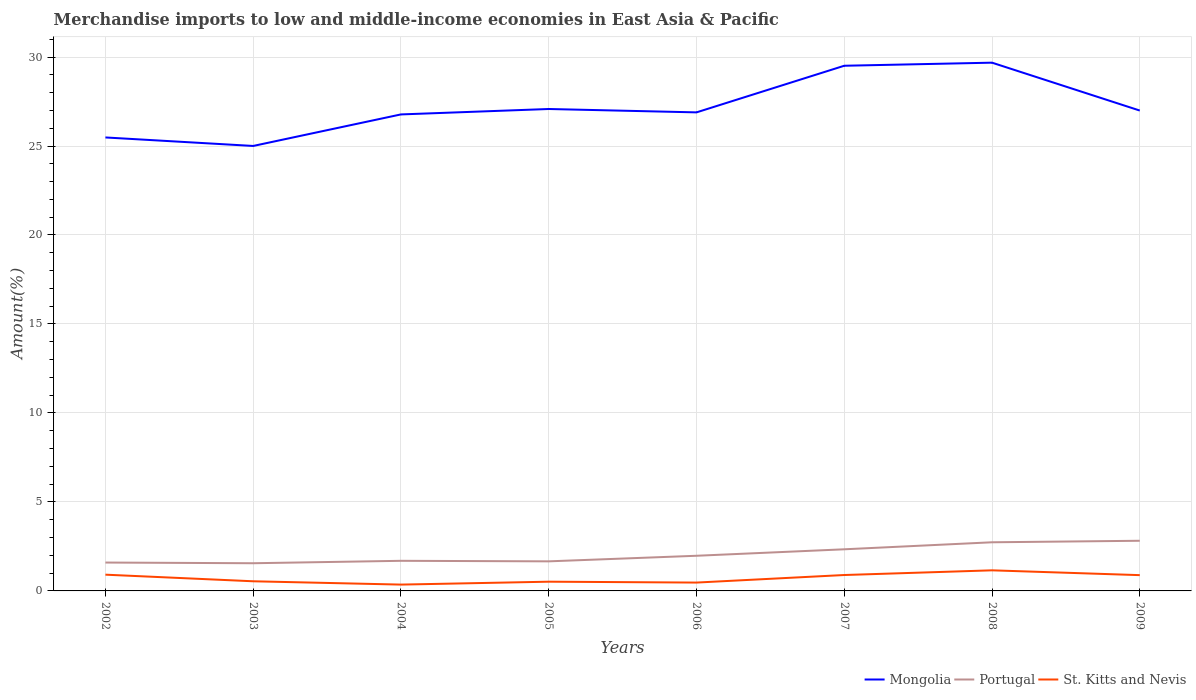Does the line corresponding to St. Kitts and Nevis intersect with the line corresponding to Portugal?
Ensure brevity in your answer.  No. Is the number of lines equal to the number of legend labels?
Your answer should be compact. Yes. Across all years, what is the maximum percentage of amount earned from merchandise imports in Mongolia?
Your answer should be compact. 25. What is the total percentage of amount earned from merchandise imports in Mongolia in the graph?
Your answer should be compact. -0.17. What is the difference between the highest and the second highest percentage of amount earned from merchandise imports in Mongolia?
Your response must be concise. 4.68. What is the difference between the highest and the lowest percentage of amount earned from merchandise imports in Mongolia?
Your answer should be compact. 2. How many lines are there?
Provide a short and direct response. 3. Are the values on the major ticks of Y-axis written in scientific E-notation?
Give a very brief answer. No. Does the graph contain any zero values?
Your answer should be compact. No. Does the graph contain grids?
Provide a succinct answer. Yes. How many legend labels are there?
Ensure brevity in your answer.  3. What is the title of the graph?
Provide a succinct answer. Merchandise imports to low and middle-income economies in East Asia & Pacific. Does "India" appear as one of the legend labels in the graph?
Make the answer very short. No. What is the label or title of the X-axis?
Make the answer very short. Years. What is the label or title of the Y-axis?
Make the answer very short. Amount(%). What is the Amount(%) of Mongolia in 2002?
Your answer should be compact. 25.48. What is the Amount(%) in Portugal in 2002?
Offer a terse response. 1.59. What is the Amount(%) of St. Kitts and Nevis in 2002?
Your response must be concise. 0.91. What is the Amount(%) of Mongolia in 2003?
Your answer should be compact. 25. What is the Amount(%) in Portugal in 2003?
Give a very brief answer. 1.56. What is the Amount(%) in St. Kitts and Nevis in 2003?
Ensure brevity in your answer.  0.54. What is the Amount(%) of Mongolia in 2004?
Offer a terse response. 26.78. What is the Amount(%) in Portugal in 2004?
Keep it short and to the point. 1.69. What is the Amount(%) of St. Kitts and Nevis in 2004?
Your answer should be compact. 0.36. What is the Amount(%) in Mongolia in 2005?
Provide a short and direct response. 27.08. What is the Amount(%) of Portugal in 2005?
Provide a succinct answer. 1.66. What is the Amount(%) in St. Kitts and Nevis in 2005?
Provide a succinct answer. 0.52. What is the Amount(%) in Mongolia in 2006?
Make the answer very short. 26.89. What is the Amount(%) in Portugal in 2006?
Provide a short and direct response. 1.98. What is the Amount(%) in St. Kitts and Nevis in 2006?
Your answer should be very brief. 0.47. What is the Amount(%) of Mongolia in 2007?
Offer a very short reply. 29.51. What is the Amount(%) in Portugal in 2007?
Give a very brief answer. 2.34. What is the Amount(%) of St. Kitts and Nevis in 2007?
Your response must be concise. 0.89. What is the Amount(%) in Mongolia in 2008?
Keep it short and to the point. 29.68. What is the Amount(%) of Portugal in 2008?
Your response must be concise. 2.73. What is the Amount(%) in St. Kitts and Nevis in 2008?
Your answer should be compact. 1.16. What is the Amount(%) of Mongolia in 2009?
Your response must be concise. 26.99. What is the Amount(%) in Portugal in 2009?
Your response must be concise. 2.82. What is the Amount(%) in St. Kitts and Nevis in 2009?
Keep it short and to the point. 0.89. Across all years, what is the maximum Amount(%) in Mongolia?
Provide a short and direct response. 29.68. Across all years, what is the maximum Amount(%) of Portugal?
Give a very brief answer. 2.82. Across all years, what is the maximum Amount(%) of St. Kitts and Nevis?
Your response must be concise. 1.16. Across all years, what is the minimum Amount(%) in Mongolia?
Provide a short and direct response. 25. Across all years, what is the minimum Amount(%) in Portugal?
Your response must be concise. 1.56. Across all years, what is the minimum Amount(%) of St. Kitts and Nevis?
Ensure brevity in your answer.  0.36. What is the total Amount(%) of Mongolia in the graph?
Provide a succinct answer. 217.42. What is the total Amount(%) in Portugal in the graph?
Keep it short and to the point. 16.37. What is the total Amount(%) of St. Kitts and Nevis in the graph?
Provide a short and direct response. 5.74. What is the difference between the Amount(%) in Mongolia in 2002 and that in 2003?
Your answer should be compact. 0.48. What is the difference between the Amount(%) of Portugal in 2002 and that in 2003?
Offer a very short reply. 0.04. What is the difference between the Amount(%) of St. Kitts and Nevis in 2002 and that in 2003?
Provide a short and direct response. 0.37. What is the difference between the Amount(%) in Mongolia in 2002 and that in 2004?
Provide a short and direct response. -1.29. What is the difference between the Amount(%) in Portugal in 2002 and that in 2004?
Provide a succinct answer. -0.1. What is the difference between the Amount(%) in St. Kitts and Nevis in 2002 and that in 2004?
Your response must be concise. 0.56. What is the difference between the Amount(%) in Mongolia in 2002 and that in 2005?
Keep it short and to the point. -1.6. What is the difference between the Amount(%) in Portugal in 2002 and that in 2005?
Provide a short and direct response. -0.07. What is the difference between the Amount(%) in St. Kitts and Nevis in 2002 and that in 2005?
Make the answer very short. 0.39. What is the difference between the Amount(%) of Mongolia in 2002 and that in 2006?
Your response must be concise. -1.41. What is the difference between the Amount(%) in Portugal in 2002 and that in 2006?
Your answer should be very brief. -0.38. What is the difference between the Amount(%) in St. Kitts and Nevis in 2002 and that in 2006?
Offer a very short reply. 0.44. What is the difference between the Amount(%) in Mongolia in 2002 and that in 2007?
Offer a very short reply. -4.03. What is the difference between the Amount(%) in Portugal in 2002 and that in 2007?
Your answer should be very brief. -0.74. What is the difference between the Amount(%) in St. Kitts and Nevis in 2002 and that in 2007?
Give a very brief answer. 0.02. What is the difference between the Amount(%) in Mongolia in 2002 and that in 2008?
Keep it short and to the point. -4.2. What is the difference between the Amount(%) of Portugal in 2002 and that in 2008?
Offer a terse response. -1.14. What is the difference between the Amount(%) in St. Kitts and Nevis in 2002 and that in 2008?
Offer a terse response. -0.24. What is the difference between the Amount(%) of Mongolia in 2002 and that in 2009?
Your answer should be compact. -1.51. What is the difference between the Amount(%) of Portugal in 2002 and that in 2009?
Offer a very short reply. -1.22. What is the difference between the Amount(%) of St. Kitts and Nevis in 2002 and that in 2009?
Give a very brief answer. 0.03. What is the difference between the Amount(%) of Mongolia in 2003 and that in 2004?
Offer a very short reply. -1.77. What is the difference between the Amount(%) of Portugal in 2003 and that in 2004?
Ensure brevity in your answer.  -0.14. What is the difference between the Amount(%) of St. Kitts and Nevis in 2003 and that in 2004?
Offer a terse response. 0.19. What is the difference between the Amount(%) of Mongolia in 2003 and that in 2005?
Give a very brief answer. -2.08. What is the difference between the Amount(%) in Portugal in 2003 and that in 2005?
Your answer should be compact. -0.11. What is the difference between the Amount(%) in St. Kitts and Nevis in 2003 and that in 2005?
Your answer should be very brief. 0.02. What is the difference between the Amount(%) of Mongolia in 2003 and that in 2006?
Offer a very short reply. -1.89. What is the difference between the Amount(%) of Portugal in 2003 and that in 2006?
Your answer should be compact. -0.42. What is the difference between the Amount(%) in St. Kitts and Nevis in 2003 and that in 2006?
Your answer should be very brief. 0.07. What is the difference between the Amount(%) in Mongolia in 2003 and that in 2007?
Your response must be concise. -4.51. What is the difference between the Amount(%) of Portugal in 2003 and that in 2007?
Provide a succinct answer. -0.78. What is the difference between the Amount(%) of St. Kitts and Nevis in 2003 and that in 2007?
Make the answer very short. -0.35. What is the difference between the Amount(%) in Mongolia in 2003 and that in 2008?
Your response must be concise. -4.68. What is the difference between the Amount(%) in Portugal in 2003 and that in 2008?
Keep it short and to the point. -1.18. What is the difference between the Amount(%) in St. Kitts and Nevis in 2003 and that in 2008?
Give a very brief answer. -0.61. What is the difference between the Amount(%) of Mongolia in 2003 and that in 2009?
Your response must be concise. -1.99. What is the difference between the Amount(%) of Portugal in 2003 and that in 2009?
Your answer should be very brief. -1.26. What is the difference between the Amount(%) of St. Kitts and Nevis in 2003 and that in 2009?
Give a very brief answer. -0.34. What is the difference between the Amount(%) in Mongolia in 2004 and that in 2005?
Your answer should be compact. -0.3. What is the difference between the Amount(%) in Portugal in 2004 and that in 2005?
Ensure brevity in your answer.  0.03. What is the difference between the Amount(%) of St. Kitts and Nevis in 2004 and that in 2005?
Provide a succinct answer. -0.16. What is the difference between the Amount(%) of Mongolia in 2004 and that in 2006?
Your response must be concise. -0.11. What is the difference between the Amount(%) of Portugal in 2004 and that in 2006?
Keep it short and to the point. -0.28. What is the difference between the Amount(%) in St. Kitts and Nevis in 2004 and that in 2006?
Keep it short and to the point. -0.11. What is the difference between the Amount(%) in Mongolia in 2004 and that in 2007?
Give a very brief answer. -2.73. What is the difference between the Amount(%) in Portugal in 2004 and that in 2007?
Give a very brief answer. -0.65. What is the difference between the Amount(%) in St. Kitts and Nevis in 2004 and that in 2007?
Provide a succinct answer. -0.54. What is the difference between the Amount(%) in Mongolia in 2004 and that in 2008?
Provide a succinct answer. -2.91. What is the difference between the Amount(%) of Portugal in 2004 and that in 2008?
Offer a terse response. -1.04. What is the difference between the Amount(%) in St. Kitts and Nevis in 2004 and that in 2008?
Provide a succinct answer. -0.8. What is the difference between the Amount(%) in Mongolia in 2004 and that in 2009?
Keep it short and to the point. -0.22. What is the difference between the Amount(%) in Portugal in 2004 and that in 2009?
Provide a succinct answer. -1.13. What is the difference between the Amount(%) of St. Kitts and Nevis in 2004 and that in 2009?
Ensure brevity in your answer.  -0.53. What is the difference between the Amount(%) in Mongolia in 2005 and that in 2006?
Make the answer very short. 0.19. What is the difference between the Amount(%) in Portugal in 2005 and that in 2006?
Your response must be concise. -0.31. What is the difference between the Amount(%) of St. Kitts and Nevis in 2005 and that in 2006?
Give a very brief answer. 0.05. What is the difference between the Amount(%) of Mongolia in 2005 and that in 2007?
Provide a short and direct response. -2.43. What is the difference between the Amount(%) of Portugal in 2005 and that in 2007?
Make the answer very short. -0.68. What is the difference between the Amount(%) of St. Kitts and Nevis in 2005 and that in 2007?
Your answer should be compact. -0.38. What is the difference between the Amount(%) in Mongolia in 2005 and that in 2008?
Offer a terse response. -2.6. What is the difference between the Amount(%) of Portugal in 2005 and that in 2008?
Make the answer very short. -1.07. What is the difference between the Amount(%) of St. Kitts and Nevis in 2005 and that in 2008?
Offer a very short reply. -0.64. What is the difference between the Amount(%) in Mongolia in 2005 and that in 2009?
Keep it short and to the point. 0.09. What is the difference between the Amount(%) of Portugal in 2005 and that in 2009?
Make the answer very short. -1.16. What is the difference between the Amount(%) of St. Kitts and Nevis in 2005 and that in 2009?
Ensure brevity in your answer.  -0.37. What is the difference between the Amount(%) in Mongolia in 2006 and that in 2007?
Keep it short and to the point. -2.62. What is the difference between the Amount(%) in Portugal in 2006 and that in 2007?
Offer a terse response. -0.36. What is the difference between the Amount(%) in St. Kitts and Nevis in 2006 and that in 2007?
Provide a succinct answer. -0.42. What is the difference between the Amount(%) of Mongolia in 2006 and that in 2008?
Make the answer very short. -2.79. What is the difference between the Amount(%) in Portugal in 2006 and that in 2008?
Keep it short and to the point. -0.76. What is the difference between the Amount(%) in St. Kitts and Nevis in 2006 and that in 2008?
Provide a succinct answer. -0.69. What is the difference between the Amount(%) of Mongolia in 2006 and that in 2009?
Keep it short and to the point. -0.1. What is the difference between the Amount(%) of Portugal in 2006 and that in 2009?
Offer a very short reply. -0.84. What is the difference between the Amount(%) of St. Kitts and Nevis in 2006 and that in 2009?
Provide a succinct answer. -0.42. What is the difference between the Amount(%) of Mongolia in 2007 and that in 2008?
Offer a very short reply. -0.17. What is the difference between the Amount(%) in Portugal in 2007 and that in 2008?
Make the answer very short. -0.39. What is the difference between the Amount(%) of St. Kitts and Nevis in 2007 and that in 2008?
Provide a short and direct response. -0.26. What is the difference between the Amount(%) of Mongolia in 2007 and that in 2009?
Offer a very short reply. 2.52. What is the difference between the Amount(%) in Portugal in 2007 and that in 2009?
Make the answer very short. -0.48. What is the difference between the Amount(%) in St. Kitts and Nevis in 2007 and that in 2009?
Ensure brevity in your answer.  0.01. What is the difference between the Amount(%) of Mongolia in 2008 and that in 2009?
Make the answer very short. 2.69. What is the difference between the Amount(%) in Portugal in 2008 and that in 2009?
Provide a succinct answer. -0.09. What is the difference between the Amount(%) of St. Kitts and Nevis in 2008 and that in 2009?
Your answer should be compact. 0.27. What is the difference between the Amount(%) of Mongolia in 2002 and the Amount(%) of Portugal in 2003?
Give a very brief answer. 23.92. What is the difference between the Amount(%) in Mongolia in 2002 and the Amount(%) in St. Kitts and Nevis in 2003?
Offer a terse response. 24.94. What is the difference between the Amount(%) of Portugal in 2002 and the Amount(%) of St. Kitts and Nevis in 2003?
Offer a very short reply. 1.05. What is the difference between the Amount(%) of Mongolia in 2002 and the Amount(%) of Portugal in 2004?
Offer a terse response. 23.79. What is the difference between the Amount(%) of Mongolia in 2002 and the Amount(%) of St. Kitts and Nevis in 2004?
Offer a terse response. 25.12. What is the difference between the Amount(%) of Portugal in 2002 and the Amount(%) of St. Kitts and Nevis in 2004?
Make the answer very short. 1.24. What is the difference between the Amount(%) in Mongolia in 2002 and the Amount(%) in Portugal in 2005?
Provide a short and direct response. 23.82. What is the difference between the Amount(%) in Mongolia in 2002 and the Amount(%) in St. Kitts and Nevis in 2005?
Offer a terse response. 24.96. What is the difference between the Amount(%) of Portugal in 2002 and the Amount(%) of St. Kitts and Nevis in 2005?
Provide a succinct answer. 1.08. What is the difference between the Amount(%) in Mongolia in 2002 and the Amount(%) in Portugal in 2006?
Make the answer very short. 23.51. What is the difference between the Amount(%) in Mongolia in 2002 and the Amount(%) in St. Kitts and Nevis in 2006?
Ensure brevity in your answer.  25.01. What is the difference between the Amount(%) of Portugal in 2002 and the Amount(%) of St. Kitts and Nevis in 2006?
Your answer should be compact. 1.13. What is the difference between the Amount(%) of Mongolia in 2002 and the Amount(%) of Portugal in 2007?
Make the answer very short. 23.14. What is the difference between the Amount(%) of Mongolia in 2002 and the Amount(%) of St. Kitts and Nevis in 2007?
Your response must be concise. 24.59. What is the difference between the Amount(%) of Portugal in 2002 and the Amount(%) of St. Kitts and Nevis in 2007?
Your response must be concise. 0.7. What is the difference between the Amount(%) in Mongolia in 2002 and the Amount(%) in Portugal in 2008?
Offer a terse response. 22.75. What is the difference between the Amount(%) in Mongolia in 2002 and the Amount(%) in St. Kitts and Nevis in 2008?
Ensure brevity in your answer.  24.32. What is the difference between the Amount(%) of Portugal in 2002 and the Amount(%) of St. Kitts and Nevis in 2008?
Ensure brevity in your answer.  0.44. What is the difference between the Amount(%) in Mongolia in 2002 and the Amount(%) in Portugal in 2009?
Ensure brevity in your answer.  22.66. What is the difference between the Amount(%) in Mongolia in 2002 and the Amount(%) in St. Kitts and Nevis in 2009?
Provide a short and direct response. 24.59. What is the difference between the Amount(%) of Portugal in 2002 and the Amount(%) of St. Kitts and Nevis in 2009?
Your answer should be compact. 0.71. What is the difference between the Amount(%) of Mongolia in 2003 and the Amount(%) of Portugal in 2004?
Ensure brevity in your answer.  23.31. What is the difference between the Amount(%) of Mongolia in 2003 and the Amount(%) of St. Kitts and Nevis in 2004?
Make the answer very short. 24.65. What is the difference between the Amount(%) of Portugal in 2003 and the Amount(%) of St. Kitts and Nevis in 2004?
Ensure brevity in your answer.  1.2. What is the difference between the Amount(%) in Mongolia in 2003 and the Amount(%) in Portugal in 2005?
Make the answer very short. 23.34. What is the difference between the Amount(%) of Mongolia in 2003 and the Amount(%) of St. Kitts and Nevis in 2005?
Offer a very short reply. 24.49. What is the difference between the Amount(%) in Portugal in 2003 and the Amount(%) in St. Kitts and Nevis in 2005?
Your answer should be very brief. 1.04. What is the difference between the Amount(%) in Mongolia in 2003 and the Amount(%) in Portugal in 2006?
Offer a very short reply. 23.03. What is the difference between the Amount(%) of Mongolia in 2003 and the Amount(%) of St. Kitts and Nevis in 2006?
Your response must be concise. 24.53. What is the difference between the Amount(%) in Portugal in 2003 and the Amount(%) in St. Kitts and Nevis in 2006?
Offer a very short reply. 1.09. What is the difference between the Amount(%) of Mongolia in 2003 and the Amount(%) of Portugal in 2007?
Offer a terse response. 22.66. What is the difference between the Amount(%) of Mongolia in 2003 and the Amount(%) of St. Kitts and Nevis in 2007?
Provide a succinct answer. 24.11. What is the difference between the Amount(%) in Portugal in 2003 and the Amount(%) in St. Kitts and Nevis in 2007?
Your answer should be very brief. 0.66. What is the difference between the Amount(%) in Mongolia in 2003 and the Amount(%) in Portugal in 2008?
Your answer should be very brief. 22.27. What is the difference between the Amount(%) in Mongolia in 2003 and the Amount(%) in St. Kitts and Nevis in 2008?
Provide a short and direct response. 23.85. What is the difference between the Amount(%) in Portugal in 2003 and the Amount(%) in St. Kitts and Nevis in 2008?
Keep it short and to the point. 0.4. What is the difference between the Amount(%) in Mongolia in 2003 and the Amount(%) in Portugal in 2009?
Make the answer very short. 22.19. What is the difference between the Amount(%) in Mongolia in 2003 and the Amount(%) in St. Kitts and Nevis in 2009?
Your answer should be compact. 24.12. What is the difference between the Amount(%) of Portugal in 2003 and the Amount(%) of St. Kitts and Nevis in 2009?
Provide a succinct answer. 0.67. What is the difference between the Amount(%) in Mongolia in 2004 and the Amount(%) in Portugal in 2005?
Your response must be concise. 25.11. What is the difference between the Amount(%) of Mongolia in 2004 and the Amount(%) of St. Kitts and Nevis in 2005?
Offer a terse response. 26.26. What is the difference between the Amount(%) in Portugal in 2004 and the Amount(%) in St. Kitts and Nevis in 2005?
Offer a terse response. 1.17. What is the difference between the Amount(%) in Mongolia in 2004 and the Amount(%) in Portugal in 2006?
Provide a short and direct response. 24.8. What is the difference between the Amount(%) in Mongolia in 2004 and the Amount(%) in St. Kitts and Nevis in 2006?
Offer a terse response. 26.31. What is the difference between the Amount(%) of Portugal in 2004 and the Amount(%) of St. Kitts and Nevis in 2006?
Make the answer very short. 1.22. What is the difference between the Amount(%) in Mongolia in 2004 and the Amount(%) in Portugal in 2007?
Provide a succinct answer. 24.44. What is the difference between the Amount(%) in Mongolia in 2004 and the Amount(%) in St. Kitts and Nevis in 2007?
Provide a short and direct response. 25.88. What is the difference between the Amount(%) of Portugal in 2004 and the Amount(%) of St. Kitts and Nevis in 2007?
Provide a succinct answer. 0.8. What is the difference between the Amount(%) in Mongolia in 2004 and the Amount(%) in Portugal in 2008?
Your response must be concise. 24.04. What is the difference between the Amount(%) in Mongolia in 2004 and the Amount(%) in St. Kitts and Nevis in 2008?
Keep it short and to the point. 25.62. What is the difference between the Amount(%) in Portugal in 2004 and the Amount(%) in St. Kitts and Nevis in 2008?
Make the answer very short. 0.53. What is the difference between the Amount(%) in Mongolia in 2004 and the Amount(%) in Portugal in 2009?
Your answer should be compact. 23.96. What is the difference between the Amount(%) in Mongolia in 2004 and the Amount(%) in St. Kitts and Nevis in 2009?
Provide a succinct answer. 25.89. What is the difference between the Amount(%) in Portugal in 2004 and the Amount(%) in St. Kitts and Nevis in 2009?
Your answer should be compact. 0.81. What is the difference between the Amount(%) of Mongolia in 2005 and the Amount(%) of Portugal in 2006?
Your answer should be very brief. 25.1. What is the difference between the Amount(%) of Mongolia in 2005 and the Amount(%) of St. Kitts and Nevis in 2006?
Keep it short and to the point. 26.61. What is the difference between the Amount(%) in Portugal in 2005 and the Amount(%) in St. Kitts and Nevis in 2006?
Your answer should be compact. 1.19. What is the difference between the Amount(%) of Mongolia in 2005 and the Amount(%) of Portugal in 2007?
Your response must be concise. 24.74. What is the difference between the Amount(%) of Mongolia in 2005 and the Amount(%) of St. Kitts and Nevis in 2007?
Your answer should be very brief. 26.19. What is the difference between the Amount(%) of Portugal in 2005 and the Amount(%) of St. Kitts and Nevis in 2007?
Offer a very short reply. 0.77. What is the difference between the Amount(%) in Mongolia in 2005 and the Amount(%) in Portugal in 2008?
Keep it short and to the point. 24.35. What is the difference between the Amount(%) of Mongolia in 2005 and the Amount(%) of St. Kitts and Nevis in 2008?
Provide a short and direct response. 25.92. What is the difference between the Amount(%) in Portugal in 2005 and the Amount(%) in St. Kitts and Nevis in 2008?
Provide a succinct answer. 0.51. What is the difference between the Amount(%) of Mongolia in 2005 and the Amount(%) of Portugal in 2009?
Give a very brief answer. 24.26. What is the difference between the Amount(%) of Mongolia in 2005 and the Amount(%) of St. Kitts and Nevis in 2009?
Your response must be concise. 26.19. What is the difference between the Amount(%) of Portugal in 2005 and the Amount(%) of St. Kitts and Nevis in 2009?
Make the answer very short. 0.78. What is the difference between the Amount(%) of Mongolia in 2006 and the Amount(%) of Portugal in 2007?
Offer a terse response. 24.55. What is the difference between the Amount(%) in Mongolia in 2006 and the Amount(%) in St. Kitts and Nevis in 2007?
Provide a succinct answer. 26. What is the difference between the Amount(%) in Portugal in 2006 and the Amount(%) in St. Kitts and Nevis in 2007?
Keep it short and to the point. 1.08. What is the difference between the Amount(%) in Mongolia in 2006 and the Amount(%) in Portugal in 2008?
Provide a short and direct response. 24.16. What is the difference between the Amount(%) in Mongolia in 2006 and the Amount(%) in St. Kitts and Nevis in 2008?
Offer a terse response. 25.73. What is the difference between the Amount(%) in Portugal in 2006 and the Amount(%) in St. Kitts and Nevis in 2008?
Provide a short and direct response. 0.82. What is the difference between the Amount(%) of Mongolia in 2006 and the Amount(%) of Portugal in 2009?
Offer a terse response. 24.07. What is the difference between the Amount(%) in Mongolia in 2006 and the Amount(%) in St. Kitts and Nevis in 2009?
Provide a succinct answer. 26. What is the difference between the Amount(%) in Portugal in 2006 and the Amount(%) in St. Kitts and Nevis in 2009?
Give a very brief answer. 1.09. What is the difference between the Amount(%) in Mongolia in 2007 and the Amount(%) in Portugal in 2008?
Provide a succinct answer. 26.78. What is the difference between the Amount(%) in Mongolia in 2007 and the Amount(%) in St. Kitts and Nevis in 2008?
Offer a very short reply. 28.35. What is the difference between the Amount(%) in Portugal in 2007 and the Amount(%) in St. Kitts and Nevis in 2008?
Provide a short and direct response. 1.18. What is the difference between the Amount(%) of Mongolia in 2007 and the Amount(%) of Portugal in 2009?
Make the answer very short. 26.69. What is the difference between the Amount(%) of Mongolia in 2007 and the Amount(%) of St. Kitts and Nevis in 2009?
Give a very brief answer. 28.62. What is the difference between the Amount(%) in Portugal in 2007 and the Amount(%) in St. Kitts and Nevis in 2009?
Your answer should be very brief. 1.45. What is the difference between the Amount(%) in Mongolia in 2008 and the Amount(%) in Portugal in 2009?
Your answer should be very brief. 26.86. What is the difference between the Amount(%) in Mongolia in 2008 and the Amount(%) in St. Kitts and Nevis in 2009?
Offer a very short reply. 28.8. What is the difference between the Amount(%) of Portugal in 2008 and the Amount(%) of St. Kitts and Nevis in 2009?
Your answer should be very brief. 1.85. What is the average Amount(%) of Mongolia per year?
Your answer should be compact. 27.18. What is the average Amount(%) of Portugal per year?
Your answer should be compact. 2.05. What is the average Amount(%) in St. Kitts and Nevis per year?
Your response must be concise. 0.72. In the year 2002, what is the difference between the Amount(%) in Mongolia and Amount(%) in Portugal?
Your answer should be very brief. 23.89. In the year 2002, what is the difference between the Amount(%) in Mongolia and Amount(%) in St. Kitts and Nevis?
Provide a short and direct response. 24.57. In the year 2002, what is the difference between the Amount(%) of Portugal and Amount(%) of St. Kitts and Nevis?
Your answer should be very brief. 0.68. In the year 2003, what is the difference between the Amount(%) of Mongolia and Amount(%) of Portugal?
Offer a terse response. 23.45. In the year 2003, what is the difference between the Amount(%) in Mongolia and Amount(%) in St. Kitts and Nevis?
Offer a terse response. 24.46. In the year 2003, what is the difference between the Amount(%) in Portugal and Amount(%) in St. Kitts and Nevis?
Provide a short and direct response. 1.01. In the year 2004, what is the difference between the Amount(%) of Mongolia and Amount(%) of Portugal?
Your answer should be compact. 25.08. In the year 2004, what is the difference between the Amount(%) of Mongolia and Amount(%) of St. Kitts and Nevis?
Keep it short and to the point. 26.42. In the year 2004, what is the difference between the Amount(%) of Portugal and Amount(%) of St. Kitts and Nevis?
Offer a terse response. 1.34. In the year 2005, what is the difference between the Amount(%) of Mongolia and Amount(%) of Portugal?
Offer a terse response. 25.42. In the year 2005, what is the difference between the Amount(%) in Mongolia and Amount(%) in St. Kitts and Nevis?
Make the answer very short. 26.56. In the year 2005, what is the difference between the Amount(%) in Portugal and Amount(%) in St. Kitts and Nevis?
Your response must be concise. 1.14. In the year 2006, what is the difference between the Amount(%) in Mongolia and Amount(%) in Portugal?
Make the answer very short. 24.91. In the year 2006, what is the difference between the Amount(%) in Mongolia and Amount(%) in St. Kitts and Nevis?
Provide a succinct answer. 26.42. In the year 2006, what is the difference between the Amount(%) in Portugal and Amount(%) in St. Kitts and Nevis?
Make the answer very short. 1.51. In the year 2007, what is the difference between the Amount(%) of Mongolia and Amount(%) of Portugal?
Keep it short and to the point. 27.17. In the year 2007, what is the difference between the Amount(%) of Mongolia and Amount(%) of St. Kitts and Nevis?
Give a very brief answer. 28.62. In the year 2007, what is the difference between the Amount(%) of Portugal and Amount(%) of St. Kitts and Nevis?
Provide a short and direct response. 1.45. In the year 2008, what is the difference between the Amount(%) of Mongolia and Amount(%) of Portugal?
Keep it short and to the point. 26.95. In the year 2008, what is the difference between the Amount(%) in Mongolia and Amount(%) in St. Kitts and Nevis?
Your response must be concise. 28.53. In the year 2008, what is the difference between the Amount(%) of Portugal and Amount(%) of St. Kitts and Nevis?
Your answer should be compact. 1.58. In the year 2009, what is the difference between the Amount(%) of Mongolia and Amount(%) of Portugal?
Make the answer very short. 24.17. In the year 2009, what is the difference between the Amount(%) of Mongolia and Amount(%) of St. Kitts and Nevis?
Your response must be concise. 26.11. In the year 2009, what is the difference between the Amount(%) in Portugal and Amount(%) in St. Kitts and Nevis?
Provide a short and direct response. 1.93. What is the ratio of the Amount(%) in Mongolia in 2002 to that in 2003?
Give a very brief answer. 1.02. What is the ratio of the Amount(%) in Portugal in 2002 to that in 2003?
Offer a very short reply. 1.02. What is the ratio of the Amount(%) of St. Kitts and Nevis in 2002 to that in 2003?
Provide a short and direct response. 1.68. What is the ratio of the Amount(%) in Mongolia in 2002 to that in 2004?
Offer a terse response. 0.95. What is the ratio of the Amount(%) of Portugal in 2002 to that in 2004?
Your answer should be compact. 0.94. What is the ratio of the Amount(%) in St. Kitts and Nevis in 2002 to that in 2004?
Your answer should be very brief. 2.56. What is the ratio of the Amount(%) of Mongolia in 2002 to that in 2005?
Make the answer very short. 0.94. What is the ratio of the Amount(%) of Portugal in 2002 to that in 2005?
Your response must be concise. 0.96. What is the ratio of the Amount(%) in St. Kitts and Nevis in 2002 to that in 2005?
Give a very brief answer. 1.76. What is the ratio of the Amount(%) of Mongolia in 2002 to that in 2006?
Ensure brevity in your answer.  0.95. What is the ratio of the Amount(%) in Portugal in 2002 to that in 2006?
Offer a very short reply. 0.81. What is the ratio of the Amount(%) in St. Kitts and Nevis in 2002 to that in 2006?
Provide a short and direct response. 1.95. What is the ratio of the Amount(%) of Mongolia in 2002 to that in 2007?
Your response must be concise. 0.86. What is the ratio of the Amount(%) of Portugal in 2002 to that in 2007?
Keep it short and to the point. 0.68. What is the ratio of the Amount(%) of St. Kitts and Nevis in 2002 to that in 2007?
Make the answer very short. 1.02. What is the ratio of the Amount(%) of Mongolia in 2002 to that in 2008?
Make the answer very short. 0.86. What is the ratio of the Amount(%) in Portugal in 2002 to that in 2008?
Provide a short and direct response. 0.58. What is the ratio of the Amount(%) in St. Kitts and Nevis in 2002 to that in 2008?
Your answer should be very brief. 0.79. What is the ratio of the Amount(%) in Mongolia in 2002 to that in 2009?
Make the answer very short. 0.94. What is the ratio of the Amount(%) in Portugal in 2002 to that in 2009?
Your answer should be very brief. 0.57. What is the ratio of the Amount(%) in St. Kitts and Nevis in 2002 to that in 2009?
Your answer should be compact. 1.03. What is the ratio of the Amount(%) of Mongolia in 2003 to that in 2004?
Offer a very short reply. 0.93. What is the ratio of the Amount(%) in Portugal in 2003 to that in 2004?
Give a very brief answer. 0.92. What is the ratio of the Amount(%) of St. Kitts and Nevis in 2003 to that in 2004?
Provide a short and direct response. 1.52. What is the ratio of the Amount(%) in Mongolia in 2003 to that in 2005?
Ensure brevity in your answer.  0.92. What is the ratio of the Amount(%) of Portugal in 2003 to that in 2005?
Offer a terse response. 0.94. What is the ratio of the Amount(%) of St. Kitts and Nevis in 2003 to that in 2005?
Your answer should be compact. 1.05. What is the ratio of the Amount(%) in Mongolia in 2003 to that in 2006?
Provide a succinct answer. 0.93. What is the ratio of the Amount(%) in Portugal in 2003 to that in 2006?
Your answer should be very brief. 0.79. What is the ratio of the Amount(%) of St. Kitts and Nevis in 2003 to that in 2006?
Provide a succinct answer. 1.15. What is the ratio of the Amount(%) of Mongolia in 2003 to that in 2007?
Provide a succinct answer. 0.85. What is the ratio of the Amount(%) of Portugal in 2003 to that in 2007?
Keep it short and to the point. 0.67. What is the ratio of the Amount(%) in St. Kitts and Nevis in 2003 to that in 2007?
Offer a terse response. 0.61. What is the ratio of the Amount(%) in Mongolia in 2003 to that in 2008?
Keep it short and to the point. 0.84. What is the ratio of the Amount(%) in Portugal in 2003 to that in 2008?
Your response must be concise. 0.57. What is the ratio of the Amount(%) in St. Kitts and Nevis in 2003 to that in 2008?
Your answer should be very brief. 0.47. What is the ratio of the Amount(%) in Mongolia in 2003 to that in 2009?
Your response must be concise. 0.93. What is the ratio of the Amount(%) in Portugal in 2003 to that in 2009?
Make the answer very short. 0.55. What is the ratio of the Amount(%) in St. Kitts and Nevis in 2003 to that in 2009?
Your response must be concise. 0.61. What is the ratio of the Amount(%) of Mongolia in 2004 to that in 2005?
Give a very brief answer. 0.99. What is the ratio of the Amount(%) in Portugal in 2004 to that in 2005?
Your answer should be compact. 1.02. What is the ratio of the Amount(%) of St. Kitts and Nevis in 2004 to that in 2005?
Your answer should be very brief. 0.69. What is the ratio of the Amount(%) of Mongolia in 2004 to that in 2006?
Provide a short and direct response. 1. What is the ratio of the Amount(%) in Portugal in 2004 to that in 2006?
Your response must be concise. 0.86. What is the ratio of the Amount(%) of St. Kitts and Nevis in 2004 to that in 2006?
Ensure brevity in your answer.  0.76. What is the ratio of the Amount(%) in Mongolia in 2004 to that in 2007?
Give a very brief answer. 0.91. What is the ratio of the Amount(%) in Portugal in 2004 to that in 2007?
Provide a succinct answer. 0.72. What is the ratio of the Amount(%) of St. Kitts and Nevis in 2004 to that in 2007?
Your answer should be very brief. 0.4. What is the ratio of the Amount(%) of Mongolia in 2004 to that in 2008?
Your answer should be very brief. 0.9. What is the ratio of the Amount(%) of Portugal in 2004 to that in 2008?
Provide a succinct answer. 0.62. What is the ratio of the Amount(%) in St. Kitts and Nevis in 2004 to that in 2008?
Your answer should be compact. 0.31. What is the ratio of the Amount(%) of Portugal in 2004 to that in 2009?
Offer a terse response. 0.6. What is the ratio of the Amount(%) of St. Kitts and Nevis in 2004 to that in 2009?
Ensure brevity in your answer.  0.4. What is the ratio of the Amount(%) of Mongolia in 2005 to that in 2006?
Your answer should be compact. 1.01. What is the ratio of the Amount(%) of Portugal in 2005 to that in 2006?
Your response must be concise. 0.84. What is the ratio of the Amount(%) of St. Kitts and Nevis in 2005 to that in 2006?
Provide a succinct answer. 1.1. What is the ratio of the Amount(%) in Mongolia in 2005 to that in 2007?
Provide a succinct answer. 0.92. What is the ratio of the Amount(%) in Portugal in 2005 to that in 2007?
Make the answer very short. 0.71. What is the ratio of the Amount(%) of St. Kitts and Nevis in 2005 to that in 2007?
Provide a succinct answer. 0.58. What is the ratio of the Amount(%) in Mongolia in 2005 to that in 2008?
Offer a very short reply. 0.91. What is the ratio of the Amount(%) of Portugal in 2005 to that in 2008?
Keep it short and to the point. 0.61. What is the ratio of the Amount(%) of St. Kitts and Nevis in 2005 to that in 2008?
Give a very brief answer. 0.45. What is the ratio of the Amount(%) in Portugal in 2005 to that in 2009?
Ensure brevity in your answer.  0.59. What is the ratio of the Amount(%) in St. Kitts and Nevis in 2005 to that in 2009?
Provide a succinct answer. 0.58. What is the ratio of the Amount(%) in Mongolia in 2006 to that in 2007?
Give a very brief answer. 0.91. What is the ratio of the Amount(%) of Portugal in 2006 to that in 2007?
Your response must be concise. 0.84. What is the ratio of the Amount(%) in St. Kitts and Nevis in 2006 to that in 2007?
Offer a terse response. 0.53. What is the ratio of the Amount(%) of Mongolia in 2006 to that in 2008?
Offer a very short reply. 0.91. What is the ratio of the Amount(%) in Portugal in 2006 to that in 2008?
Your answer should be compact. 0.72. What is the ratio of the Amount(%) in St. Kitts and Nevis in 2006 to that in 2008?
Offer a terse response. 0.41. What is the ratio of the Amount(%) of Mongolia in 2006 to that in 2009?
Your response must be concise. 1. What is the ratio of the Amount(%) of Portugal in 2006 to that in 2009?
Provide a short and direct response. 0.7. What is the ratio of the Amount(%) in St. Kitts and Nevis in 2006 to that in 2009?
Offer a terse response. 0.53. What is the ratio of the Amount(%) of Mongolia in 2007 to that in 2008?
Your answer should be compact. 0.99. What is the ratio of the Amount(%) of Portugal in 2007 to that in 2008?
Offer a very short reply. 0.86. What is the ratio of the Amount(%) in St. Kitts and Nevis in 2007 to that in 2008?
Offer a very short reply. 0.77. What is the ratio of the Amount(%) in Mongolia in 2007 to that in 2009?
Your response must be concise. 1.09. What is the ratio of the Amount(%) of Portugal in 2007 to that in 2009?
Give a very brief answer. 0.83. What is the ratio of the Amount(%) of St. Kitts and Nevis in 2007 to that in 2009?
Ensure brevity in your answer.  1.01. What is the ratio of the Amount(%) of Mongolia in 2008 to that in 2009?
Keep it short and to the point. 1.1. What is the ratio of the Amount(%) in Portugal in 2008 to that in 2009?
Provide a short and direct response. 0.97. What is the ratio of the Amount(%) in St. Kitts and Nevis in 2008 to that in 2009?
Provide a succinct answer. 1.3. What is the difference between the highest and the second highest Amount(%) in Mongolia?
Offer a very short reply. 0.17. What is the difference between the highest and the second highest Amount(%) of Portugal?
Your response must be concise. 0.09. What is the difference between the highest and the second highest Amount(%) in St. Kitts and Nevis?
Your response must be concise. 0.24. What is the difference between the highest and the lowest Amount(%) of Mongolia?
Your response must be concise. 4.68. What is the difference between the highest and the lowest Amount(%) of Portugal?
Make the answer very short. 1.26. What is the difference between the highest and the lowest Amount(%) of St. Kitts and Nevis?
Your answer should be very brief. 0.8. 